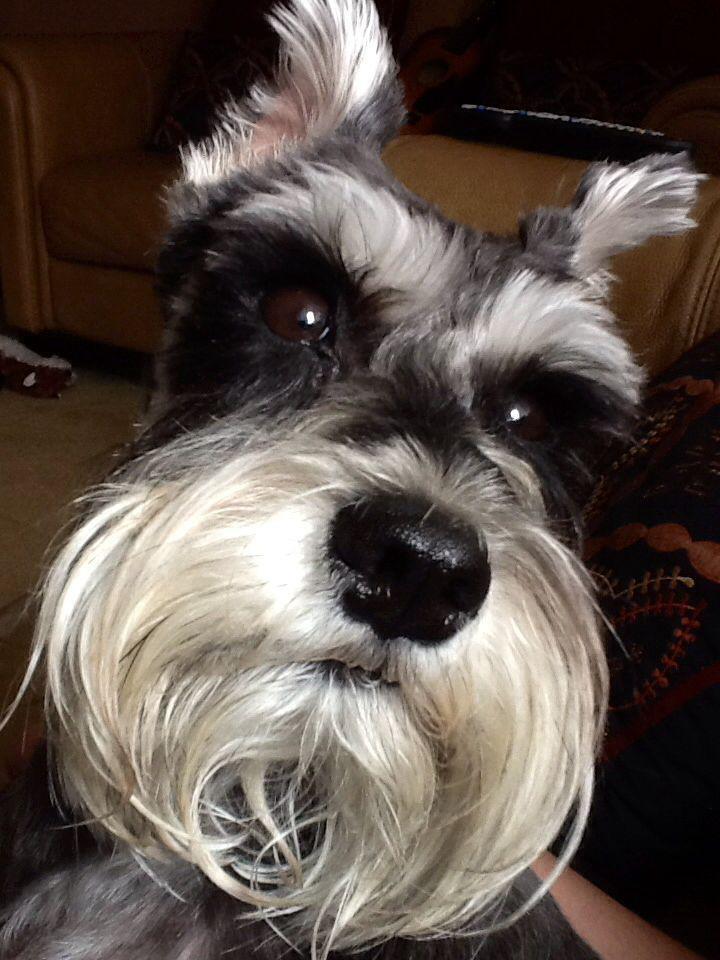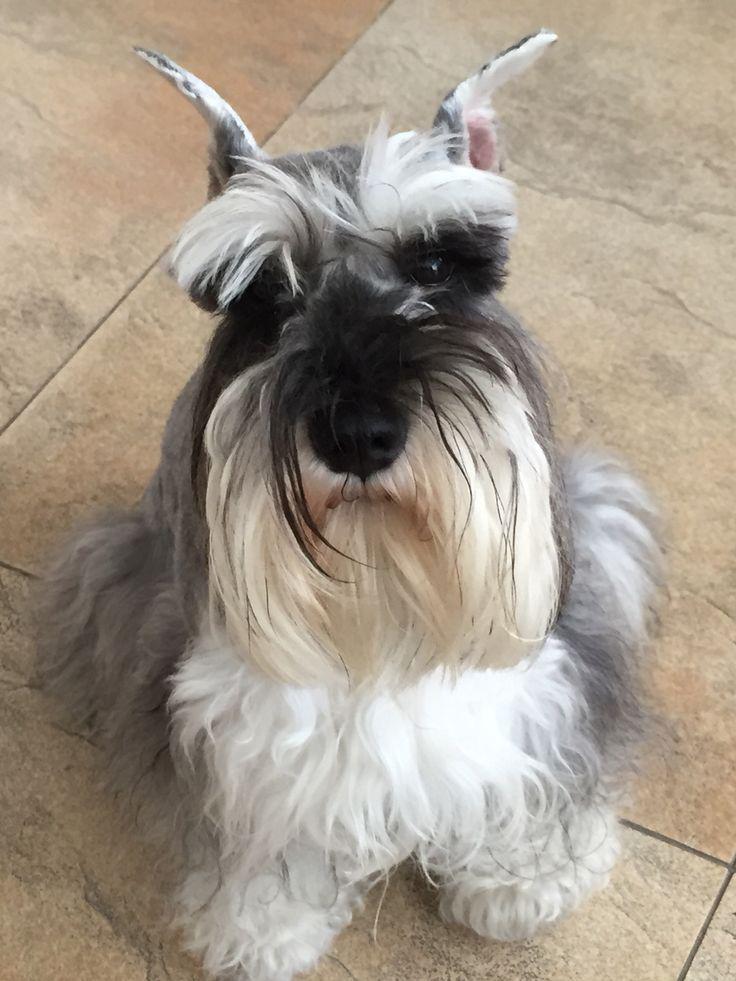The first image is the image on the left, the second image is the image on the right. Given the left and right images, does the statement "Each image shows a single schnauzer that is not in costume, and at least one image features a dog with its tongue sticking out." hold true? Answer yes or no. No. The first image is the image on the left, the second image is the image on the right. For the images displayed, is the sentence "The dog in at least one of the images has its tongue hanging out." factually correct? Answer yes or no. No. 